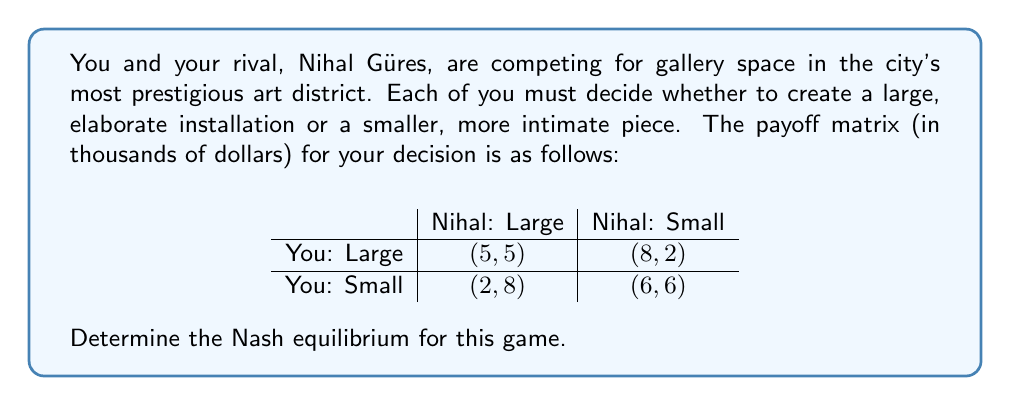Teach me how to tackle this problem. To find the Nash equilibrium, we need to analyze each player's best response to the other player's strategy.

1. Your perspective:
   - If Nihal chooses Large, your best response is Large (5 > 2)
   - If Nihal chooses Small, your best response is Large (8 > 6)

2. Nihal's perspective:
   - If you choose Large, Nihal's best response is Large (5 > 2)
   - If you choose Small, Nihal's best response is Large (8 > 6)

3. Identifying the Nash equilibrium:
   A Nash equilibrium occurs when neither player can unilaterally improve their payoff by changing their strategy.

   In this case, we can see that (Large, Large) is a Nash equilibrium because:
   - When you choose Large, Nihal's best response is Large
   - When Nihal chooses Large, your best response is Large

   Neither player has an incentive to deviate from this strategy.

4. Checking for other equilibria:
   There are no other Nash equilibria in this game because in all other scenarios, at least one player would benefit from changing their strategy.

Therefore, the unique Nash equilibrium in this game is (Large, Large), where both you and Nihal create large, elaborate installations.
Answer: The Nash equilibrium is (Large, Large), with payoffs (5, 5). 